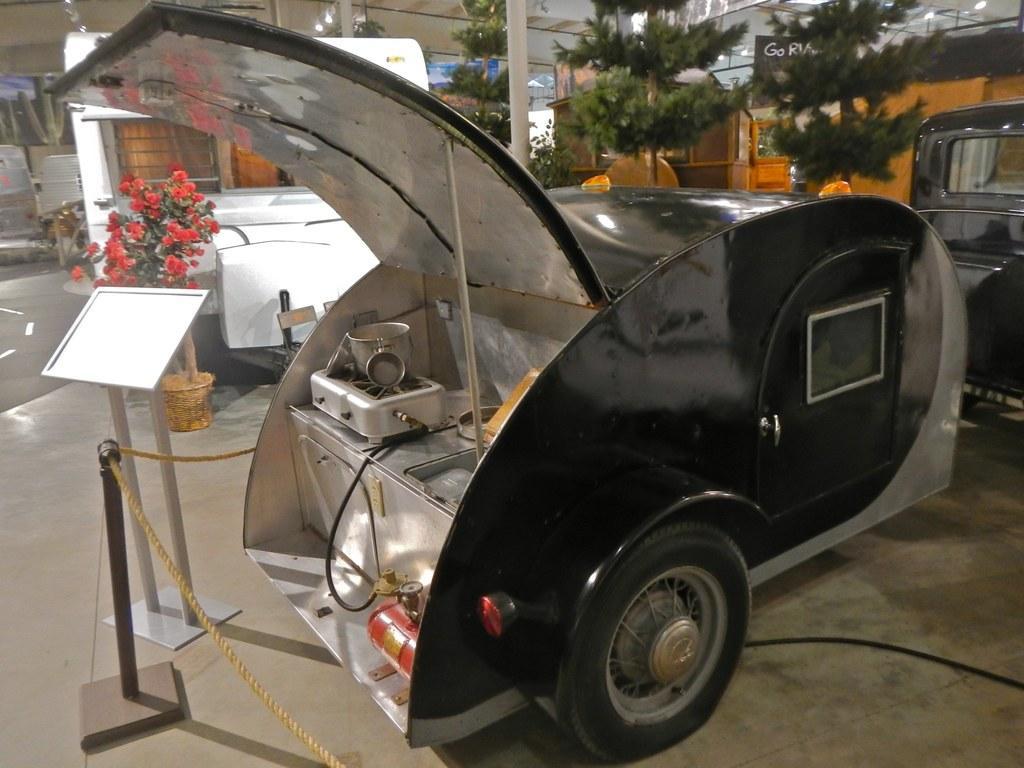Describe this image in one or two sentences. In the background we can see trees, pillars. Here we can see a small truck and a container on a stove. We can see a podium near to a truck. We can see ropes and a stand. We can see flower plant with pot. 